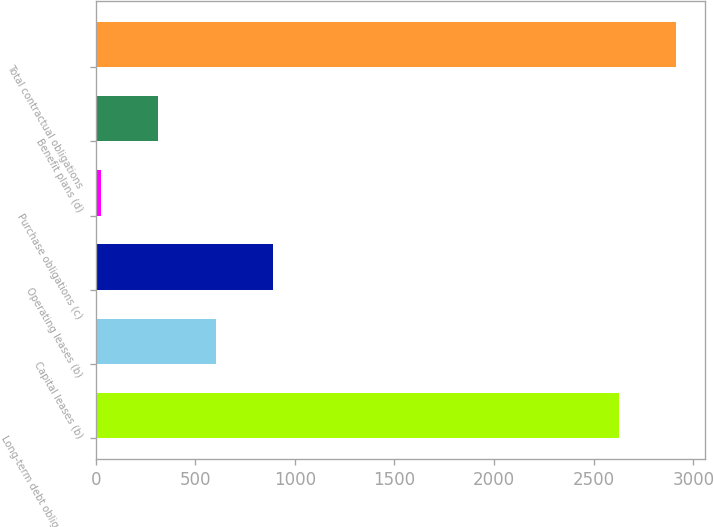<chart> <loc_0><loc_0><loc_500><loc_500><bar_chart><fcel>Long-term debt obligations (a)<fcel>Capital leases (b)<fcel>Operating leases (b)<fcel>Purchase obligations (c)<fcel>Benefit plans (d)<fcel>Total contractual obligations<nl><fcel>2628<fcel>602.2<fcel>889.3<fcel>28<fcel>315.1<fcel>2915.1<nl></chart> 